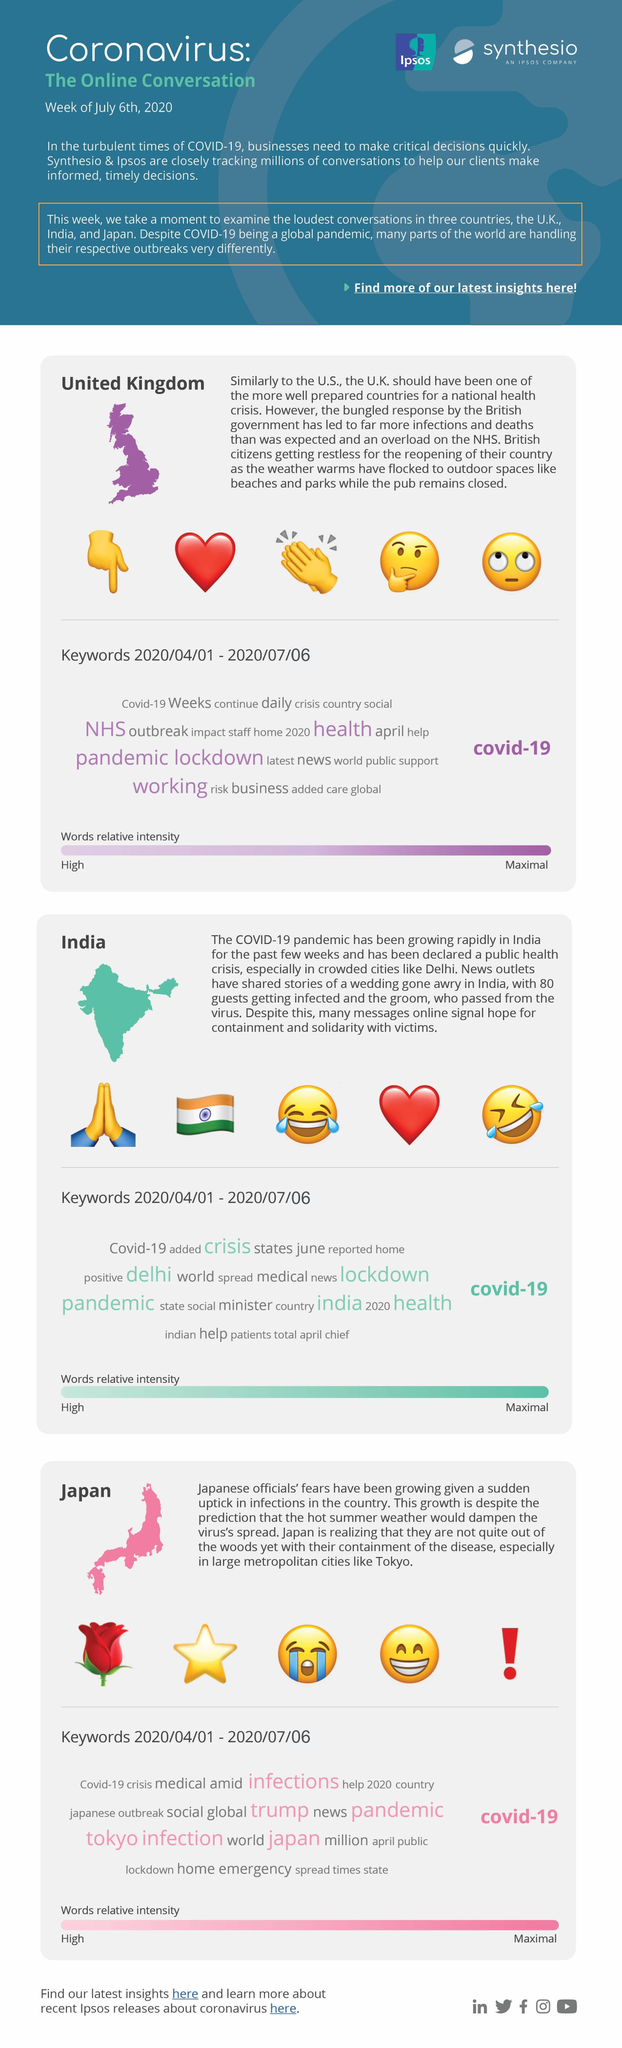List a handful of essential elements in this visual. During the COVID-19 pandemic in Japan, the term 'infections' was mentioned more frequently than 'outbreak' and 'lockdown' combined. In the UK, the term "pandemic" was discussed more than "outbreak" and "crisis" in regards to the recent COVID-19 pandemic. In India, the keyword "lockdown" was discussed more than "medical" or "positive. 